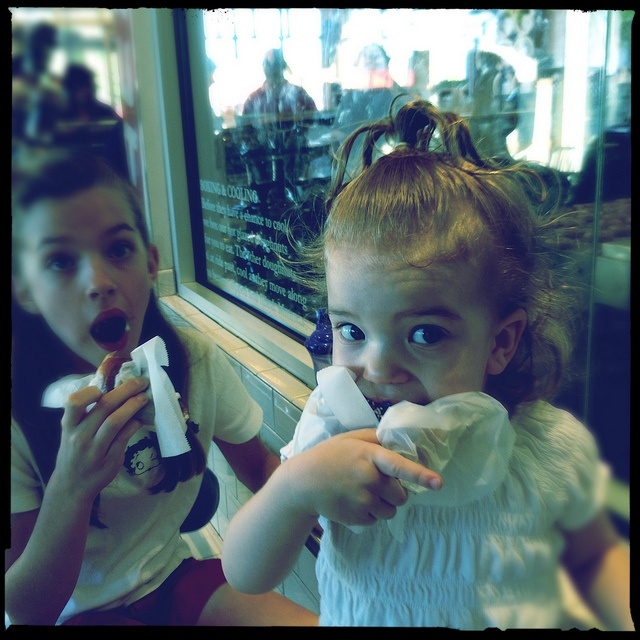Describe the objects in this image and their specific colors. I can see people in black, gray, navy, teal, and darkgray tones, people in black, navy, gray, blue, and teal tones, people in black, navy, blue, and teal tones, people in black, teal, blue, and lightblue tones, and people in black, navy, darkblue, gray, and darkgray tones in this image. 